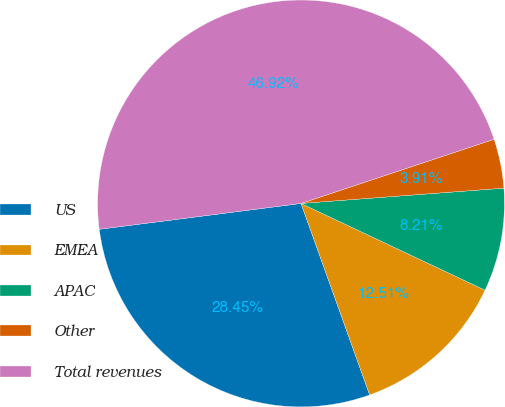<chart> <loc_0><loc_0><loc_500><loc_500><pie_chart><fcel>US<fcel>EMEA<fcel>APAC<fcel>Other<fcel>Total revenues<nl><fcel>28.45%<fcel>12.51%<fcel>8.21%<fcel>3.91%<fcel>46.92%<nl></chart> 